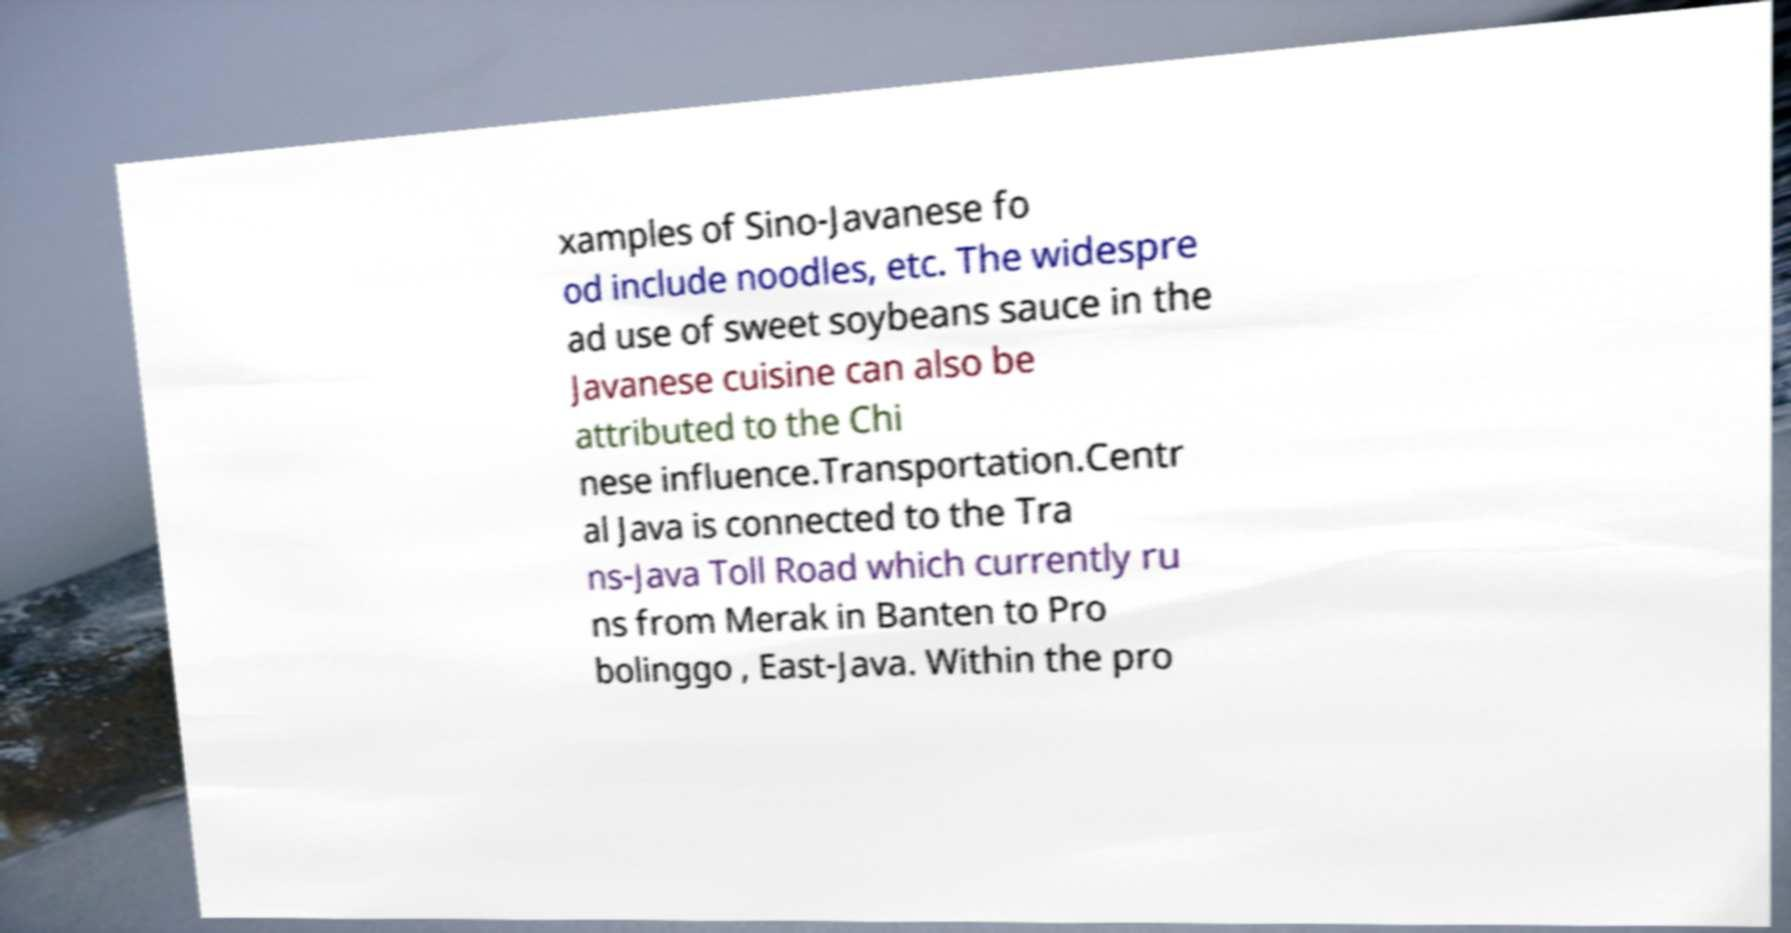What messages or text are displayed in this image? I need them in a readable, typed format. xamples of Sino-Javanese fo od include noodles, etc. The widespre ad use of sweet soybeans sauce in the Javanese cuisine can also be attributed to the Chi nese influence.Transportation.Centr al Java is connected to the Tra ns-Java Toll Road which currently ru ns from Merak in Banten to Pro bolinggo , East-Java. Within the pro 